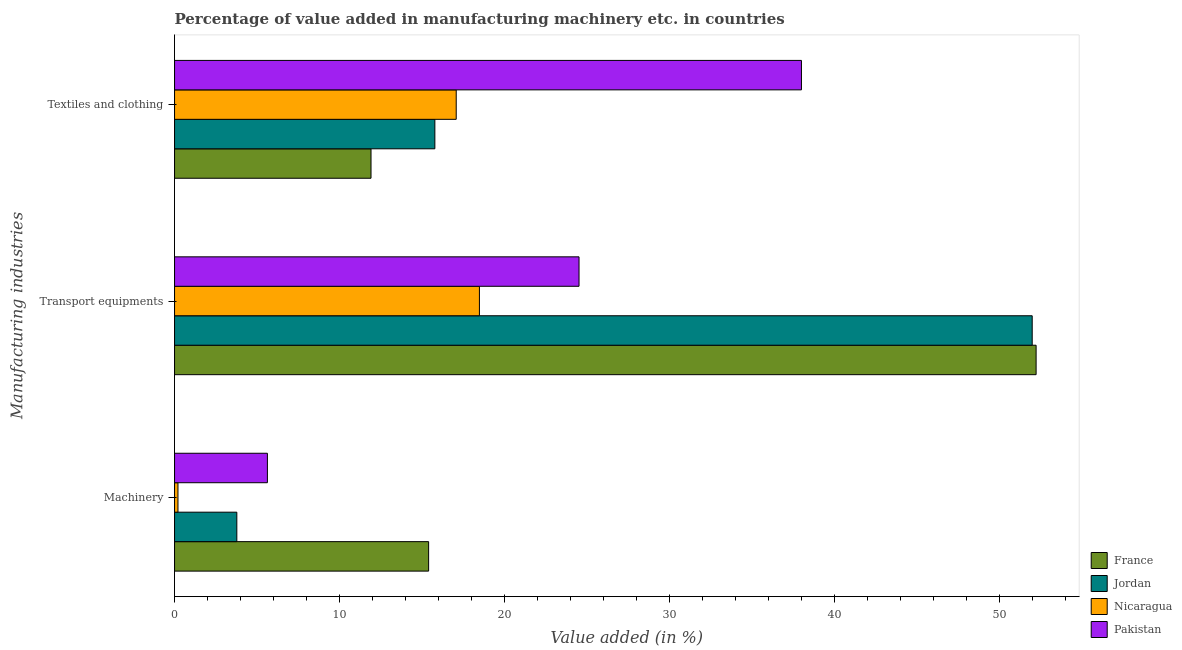How many groups of bars are there?
Offer a terse response. 3. How many bars are there on the 1st tick from the bottom?
Your response must be concise. 4. What is the label of the 2nd group of bars from the top?
Keep it short and to the point. Transport equipments. What is the value added in manufacturing machinery in Pakistan?
Your response must be concise. 5.63. Across all countries, what is the maximum value added in manufacturing machinery?
Ensure brevity in your answer.  15.4. Across all countries, what is the minimum value added in manufacturing textile and clothing?
Provide a short and direct response. 11.91. In which country was the value added in manufacturing machinery maximum?
Give a very brief answer. France. In which country was the value added in manufacturing transport equipments minimum?
Ensure brevity in your answer.  Nicaragua. What is the total value added in manufacturing transport equipments in the graph?
Keep it short and to the point. 147.2. What is the difference between the value added in manufacturing transport equipments in Nicaragua and that in Pakistan?
Ensure brevity in your answer.  -6.04. What is the difference between the value added in manufacturing textile and clothing in Nicaragua and the value added in manufacturing transport equipments in Pakistan?
Make the answer very short. -7.44. What is the average value added in manufacturing transport equipments per country?
Offer a terse response. 36.8. What is the difference between the value added in manufacturing textile and clothing and value added in manufacturing transport equipments in Pakistan?
Provide a short and direct response. 13.48. What is the ratio of the value added in manufacturing machinery in Jordan to that in France?
Ensure brevity in your answer.  0.25. Is the value added in manufacturing machinery in Pakistan less than that in France?
Ensure brevity in your answer.  Yes. What is the difference between the highest and the second highest value added in manufacturing transport equipments?
Provide a short and direct response. 0.24. What is the difference between the highest and the lowest value added in manufacturing textile and clothing?
Offer a terse response. 26.09. In how many countries, is the value added in manufacturing textile and clothing greater than the average value added in manufacturing textile and clothing taken over all countries?
Offer a terse response. 1. Is the sum of the value added in manufacturing transport equipments in Jordan and Pakistan greater than the maximum value added in manufacturing textile and clothing across all countries?
Make the answer very short. Yes. What does the 3rd bar from the bottom in Transport equipments represents?
Offer a terse response. Nicaragua. Is it the case that in every country, the sum of the value added in manufacturing machinery and value added in manufacturing transport equipments is greater than the value added in manufacturing textile and clothing?
Provide a succinct answer. No. How many bars are there?
Your response must be concise. 12. What is the difference between two consecutive major ticks on the X-axis?
Ensure brevity in your answer.  10. Where does the legend appear in the graph?
Your response must be concise. Bottom right. What is the title of the graph?
Offer a terse response. Percentage of value added in manufacturing machinery etc. in countries. Does "Lithuania" appear as one of the legend labels in the graph?
Give a very brief answer. No. What is the label or title of the X-axis?
Your response must be concise. Value added (in %). What is the label or title of the Y-axis?
Provide a short and direct response. Manufacturing industries. What is the Value added (in %) in France in Machinery?
Provide a succinct answer. 15.4. What is the Value added (in %) in Jordan in Machinery?
Keep it short and to the point. 3.77. What is the Value added (in %) in Nicaragua in Machinery?
Keep it short and to the point. 0.21. What is the Value added (in %) of Pakistan in Machinery?
Offer a very short reply. 5.63. What is the Value added (in %) in France in Transport equipments?
Your answer should be compact. 52.22. What is the Value added (in %) of Jordan in Transport equipments?
Your answer should be very brief. 51.98. What is the Value added (in %) of Nicaragua in Transport equipments?
Provide a short and direct response. 18.48. What is the Value added (in %) in Pakistan in Transport equipments?
Give a very brief answer. 24.52. What is the Value added (in %) in France in Textiles and clothing?
Offer a very short reply. 11.91. What is the Value added (in %) in Jordan in Textiles and clothing?
Your answer should be very brief. 15.78. What is the Value added (in %) of Nicaragua in Textiles and clothing?
Your answer should be compact. 17.07. What is the Value added (in %) in Pakistan in Textiles and clothing?
Offer a terse response. 38. Across all Manufacturing industries, what is the maximum Value added (in %) in France?
Your response must be concise. 52.22. Across all Manufacturing industries, what is the maximum Value added (in %) of Jordan?
Your response must be concise. 51.98. Across all Manufacturing industries, what is the maximum Value added (in %) in Nicaragua?
Provide a short and direct response. 18.48. Across all Manufacturing industries, what is the maximum Value added (in %) in Pakistan?
Provide a succinct answer. 38. Across all Manufacturing industries, what is the minimum Value added (in %) in France?
Offer a terse response. 11.91. Across all Manufacturing industries, what is the minimum Value added (in %) of Jordan?
Your answer should be compact. 3.77. Across all Manufacturing industries, what is the minimum Value added (in %) in Nicaragua?
Keep it short and to the point. 0.21. Across all Manufacturing industries, what is the minimum Value added (in %) in Pakistan?
Keep it short and to the point. 5.63. What is the total Value added (in %) in France in the graph?
Your answer should be compact. 79.53. What is the total Value added (in %) of Jordan in the graph?
Offer a very short reply. 71.53. What is the total Value added (in %) in Nicaragua in the graph?
Keep it short and to the point. 35.76. What is the total Value added (in %) of Pakistan in the graph?
Keep it short and to the point. 68.14. What is the difference between the Value added (in %) of France in Machinery and that in Transport equipments?
Keep it short and to the point. -36.82. What is the difference between the Value added (in %) in Jordan in Machinery and that in Transport equipments?
Offer a terse response. -48.21. What is the difference between the Value added (in %) of Nicaragua in Machinery and that in Transport equipments?
Offer a very short reply. -18.27. What is the difference between the Value added (in %) of Pakistan in Machinery and that in Transport equipments?
Offer a terse response. -18.89. What is the difference between the Value added (in %) in France in Machinery and that in Textiles and clothing?
Ensure brevity in your answer.  3.49. What is the difference between the Value added (in %) of Jordan in Machinery and that in Textiles and clothing?
Give a very brief answer. -12. What is the difference between the Value added (in %) of Nicaragua in Machinery and that in Textiles and clothing?
Provide a succinct answer. -16.86. What is the difference between the Value added (in %) of Pakistan in Machinery and that in Textiles and clothing?
Offer a terse response. -32.37. What is the difference between the Value added (in %) of France in Transport equipments and that in Textiles and clothing?
Make the answer very short. 40.31. What is the difference between the Value added (in %) in Jordan in Transport equipments and that in Textiles and clothing?
Your response must be concise. 36.2. What is the difference between the Value added (in %) of Nicaragua in Transport equipments and that in Textiles and clothing?
Make the answer very short. 1.41. What is the difference between the Value added (in %) of Pakistan in Transport equipments and that in Textiles and clothing?
Give a very brief answer. -13.48. What is the difference between the Value added (in %) in France in Machinery and the Value added (in %) in Jordan in Transport equipments?
Offer a very short reply. -36.58. What is the difference between the Value added (in %) in France in Machinery and the Value added (in %) in Nicaragua in Transport equipments?
Your response must be concise. -3.08. What is the difference between the Value added (in %) in France in Machinery and the Value added (in %) in Pakistan in Transport equipments?
Give a very brief answer. -9.12. What is the difference between the Value added (in %) of Jordan in Machinery and the Value added (in %) of Nicaragua in Transport equipments?
Keep it short and to the point. -14.7. What is the difference between the Value added (in %) in Jordan in Machinery and the Value added (in %) in Pakistan in Transport equipments?
Give a very brief answer. -20.74. What is the difference between the Value added (in %) in Nicaragua in Machinery and the Value added (in %) in Pakistan in Transport equipments?
Keep it short and to the point. -24.31. What is the difference between the Value added (in %) in France in Machinery and the Value added (in %) in Jordan in Textiles and clothing?
Your answer should be very brief. -0.38. What is the difference between the Value added (in %) in France in Machinery and the Value added (in %) in Nicaragua in Textiles and clothing?
Provide a short and direct response. -1.67. What is the difference between the Value added (in %) in France in Machinery and the Value added (in %) in Pakistan in Textiles and clothing?
Your answer should be very brief. -22.6. What is the difference between the Value added (in %) of Jordan in Machinery and the Value added (in %) of Nicaragua in Textiles and clothing?
Provide a succinct answer. -13.3. What is the difference between the Value added (in %) of Jordan in Machinery and the Value added (in %) of Pakistan in Textiles and clothing?
Provide a short and direct response. -34.22. What is the difference between the Value added (in %) of Nicaragua in Machinery and the Value added (in %) of Pakistan in Textiles and clothing?
Ensure brevity in your answer.  -37.79. What is the difference between the Value added (in %) of France in Transport equipments and the Value added (in %) of Jordan in Textiles and clothing?
Give a very brief answer. 36.44. What is the difference between the Value added (in %) in France in Transport equipments and the Value added (in %) in Nicaragua in Textiles and clothing?
Provide a short and direct response. 35.15. What is the difference between the Value added (in %) of France in Transport equipments and the Value added (in %) of Pakistan in Textiles and clothing?
Provide a succinct answer. 14.22. What is the difference between the Value added (in %) in Jordan in Transport equipments and the Value added (in %) in Nicaragua in Textiles and clothing?
Provide a succinct answer. 34.91. What is the difference between the Value added (in %) in Jordan in Transport equipments and the Value added (in %) in Pakistan in Textiles and clothing?
Your answer should be very brief. 13.99. What is the difference between the Value added (in %) in Nicaragua in Transport equipments and the Value added (in %) in Pakistan in Textiles and clothing?
Your response must be concise. -19.52. What is the average Value added (in %) in France per Manufacturing industries?
Provide a short and direct response. 26.51. What is the average Value added (in %) in Jordan per Manufacturing industries?
Your answer should be compact. 23.84. What is the average Value added (in %) of Nicaragua per Manufacturing industries?
Offer a very short reply. 11.92. What is the average Value added (in %) in Pakistan per Manufacturing industries?
Give a very brief answer. 22.71. What is the difference between the Value added (in %) in France and Value added (in %) in Jordan in Machinery?
Ensure brevity in your answer.  11.62. What is the difference between the Value added (in %) of France and Value added (in %) of Nicaragua in Machinery?
Your response must be concise. 15.19. What is the difference between the Value added (in %) in France and Value added (in %) in Pakistan in Machinery?
Your answer should be very brief. 9.77. What is the difference between the Value added (in %) in Jordan and Value added (in %) in Nicaragua in Machinery?
Ensure brevity in your answer.  3.57. What is the difference between the Value added (in %) in Jordan and Value added (in %) in Pakistan in Machinery?
Offer a terse response. -1.85. What is the difference between the Value added (in %) of Nicaragua and Value added (in %) of Pakistan in Machinery?
Make the answer very short. -5.42. What is the difference between the Value added (in %) of France and Value added (in %) of Jordan in Transport equipments?
Your answer should be very brief. 0.24. What is the difference between the Value added (in %) of France and Value added (in %) of Nicaragua in Transport equipments?
Offer a terse response. 33.74. What is the difference between the Value added (in %) in France and Value added (in %) in Pakistan in Transport equipments?
Make the answer very short. 27.7. What is the difference between the Value added (in %) of Jordan and Value added (in %) of Nicaragua in Transport equipments?
Your response must be concise. 33.5. What is the difference between the Value added (in %) of Jordan and Value added (in %) of Pakistan in Transport equipments?
Provide a succinct answer. 27.47. What is the difference between the Value added (in %) of Nicaragua and Value added (in %) of Pakistan in Transport equipments?
Offer a very short reply. -6.04. What is the difference between the Value added (in %) in France and Value added (in %) in Jordan in Textiles and clothing?
Keep it short and to the point. -3.87. What is the difference between the Value added (in %) in France and Value added (in %) in Nicaragua in Textiles and clothing?
Keep it short and to the point. -5.16. What is the difference between the Value added (in %) of France and Value added (in %) of Pakistan in Textiles and clothing?
Provide a succinct answer. -26.09. What is the difference between the Value added (in %) in Jordan and Value added (in %) in Nicaragua in Textiles and clothing?
Give a very brief answer. -1.29. What is the difference between the Value added (in %) of Jordan and Value added (in %) of Pakistan in Textiles and clothing?
Your answer should be compact. -22.22. What is the difference between the Value added (in %) in Nicaragua and Value added (in %) in Pakistan in Textiles and clothing?
Make the answer very short. -20.92. What is the ratio of the Value added (in %) in France in Machinery to that in Transport equipments?
Your answer should be compact. 0.29. What is the ratio of the Value added (in %) in Jordan in Machinery to that in Transport equipments?
Ensure brevity in your answer.  0.07. What is the ratio of the Value added (in %) of Nicaragua in Machinery to that in Transport equipments?
Your answer should be compact. 0.01. What is the ratio of the Value added (in %) in Pakistan in Machinery to that in Transport equipments?
Offer a terse response. 0.23. What is the ratio of the Value added (in %) in France in Machinery to that in Textiles and clothing?
Give a very brief answer. 1.29. What is the ratio of the Value added (in %) in Jordan in Machinery to that in Textiles and clothing?
Make the answer very short. 0.24. What is the ratio of the Value added (in %) of Nicaragua in Machinery to that in Textiles and clothing?
Give a very brief answer. 0.01. What is the ratio of the Value added (in %) in Pakistan in Machinery to that in Textiles and clothing?
Make the answer very short. 0.15. What is the ratio of the Value added (in %) of France in Transport equipments to that in Textiles and clothing?
Your answer should be compact. 4.39. What is the ratio of the Value added (in %) in Jordan in Transport equipments to that in Textiles and clothing?
Your answer should be compact. 3.29. What is the ratio of the Value added (in %) in Nicaragua in Transport equipments to that in Textiles and clothing?
Ensure brevity in your answer.  1.08. What is the ratio of the Value added (in %) in Pakistan in Transport equipments to that in Textiles and clothing?
Your answer should be compact. 0.65. What is the difference between the highest and the second highest Value added (in %) in France?
Offer a very short reply. 36.82. What is the difference between the highest and the second highest Value added (in %) of Jordan?
Keep it short and to the point. 36.2. What is the difference between the highest and the second highest Value added (in %) in Nicaragua?
Your response must be concise. 1.41. What is the difference between the highest and the second highest Value added (in %) of Pakistan?
Your answer should be compact. 13.48. What is the difference between the highest and the lowest Value added (in %) of France?
Your answer should be compact. 40.31. What is the difference between the highest and the lowest Value added (in %) of Jordan?
Provide a succinct answer. 48.21. What is the difference between the highest and the lowest Value added (in %) in Nicaragua?
Offer a terse response. 18.27. What is the difference between the highest and the lowest Value added (in %) in Pakistan?
Give a very brief answer. 32.37. 